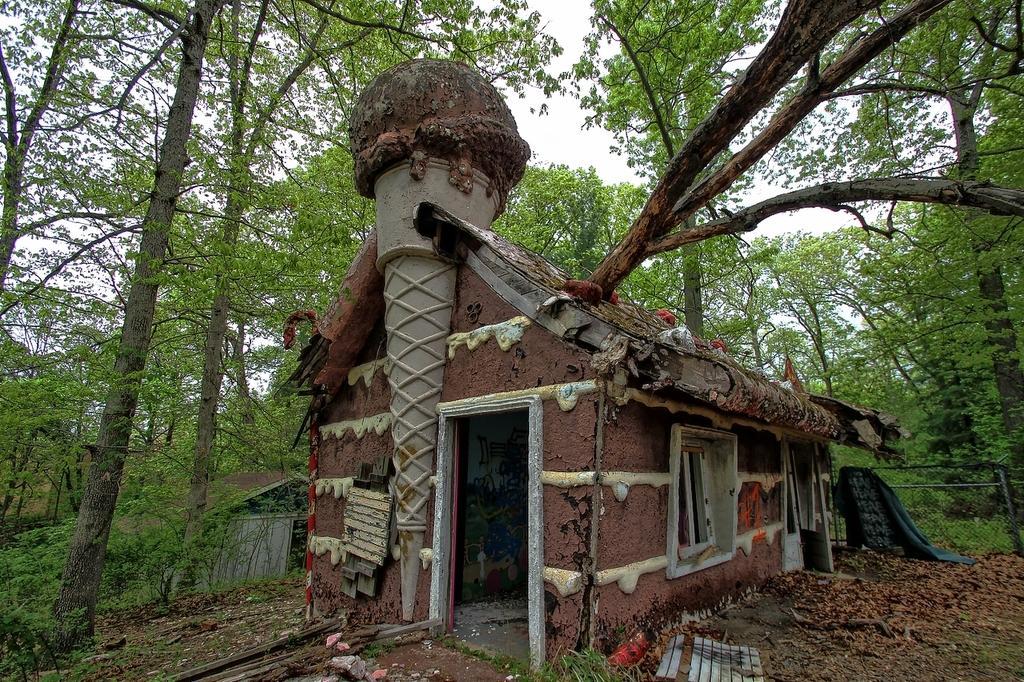Can you describe this image briefly? In this picture we can see sheds, dried leaves and some objects on the ground, here we can see a fence and trees and we can see sky in the background. 